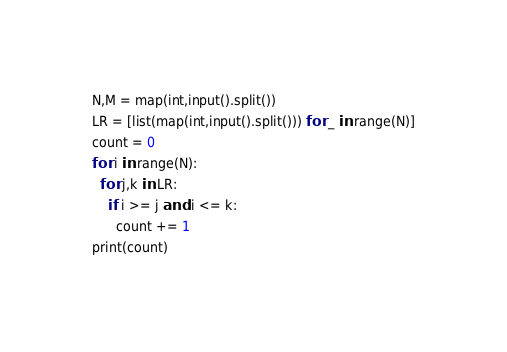Convert code to text. <code><loc_0><loc_0><loc_500><loc_500><_Python_>N,M = map(int,input().split())
LR = [list(map(int,input().split())) for _ in range(N)]
count = 0
for i in range(N):
  for j,k in LR:
    if i >= j and i <= k:
      count += 1
print(count)
</code> 